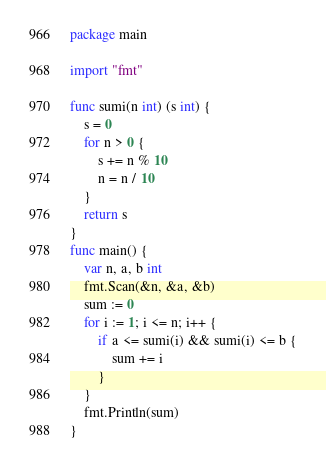Convert code to text. <code><loc_0><loc_0><loc_500><loc_500><_Go_>package main

import "fmt"

func sumi(n int) (s int) {
	s = 0
	for n > 0 {
		s += n % 10
		n = n / 10
	}
	return s
}
func main() {
	var n, a, b int
	fmt.Scan(&n, &a, &b)
	sum := 0
	for i := 1; i <= n; i++ {
		if a <= sumi(i) && sumi(i) <= b {
			sum += i
		}
	}
	fmt.Println(sum)
}
</code> 